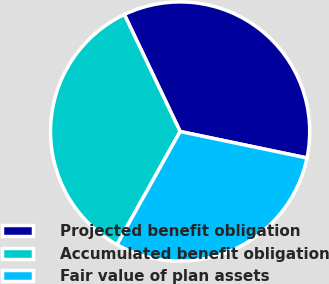Convert chart to OTSL. <chart><loc_0><loc_0><loc_500><loc_500><pie_chart><fcel>Projected benefit obligation<fcel>Accumulated benefit obligation<fcel>Fair value of plan assets<nl><fcel>35.35%<fcel>34.81%<fcel>29.83%<nl></chart> 